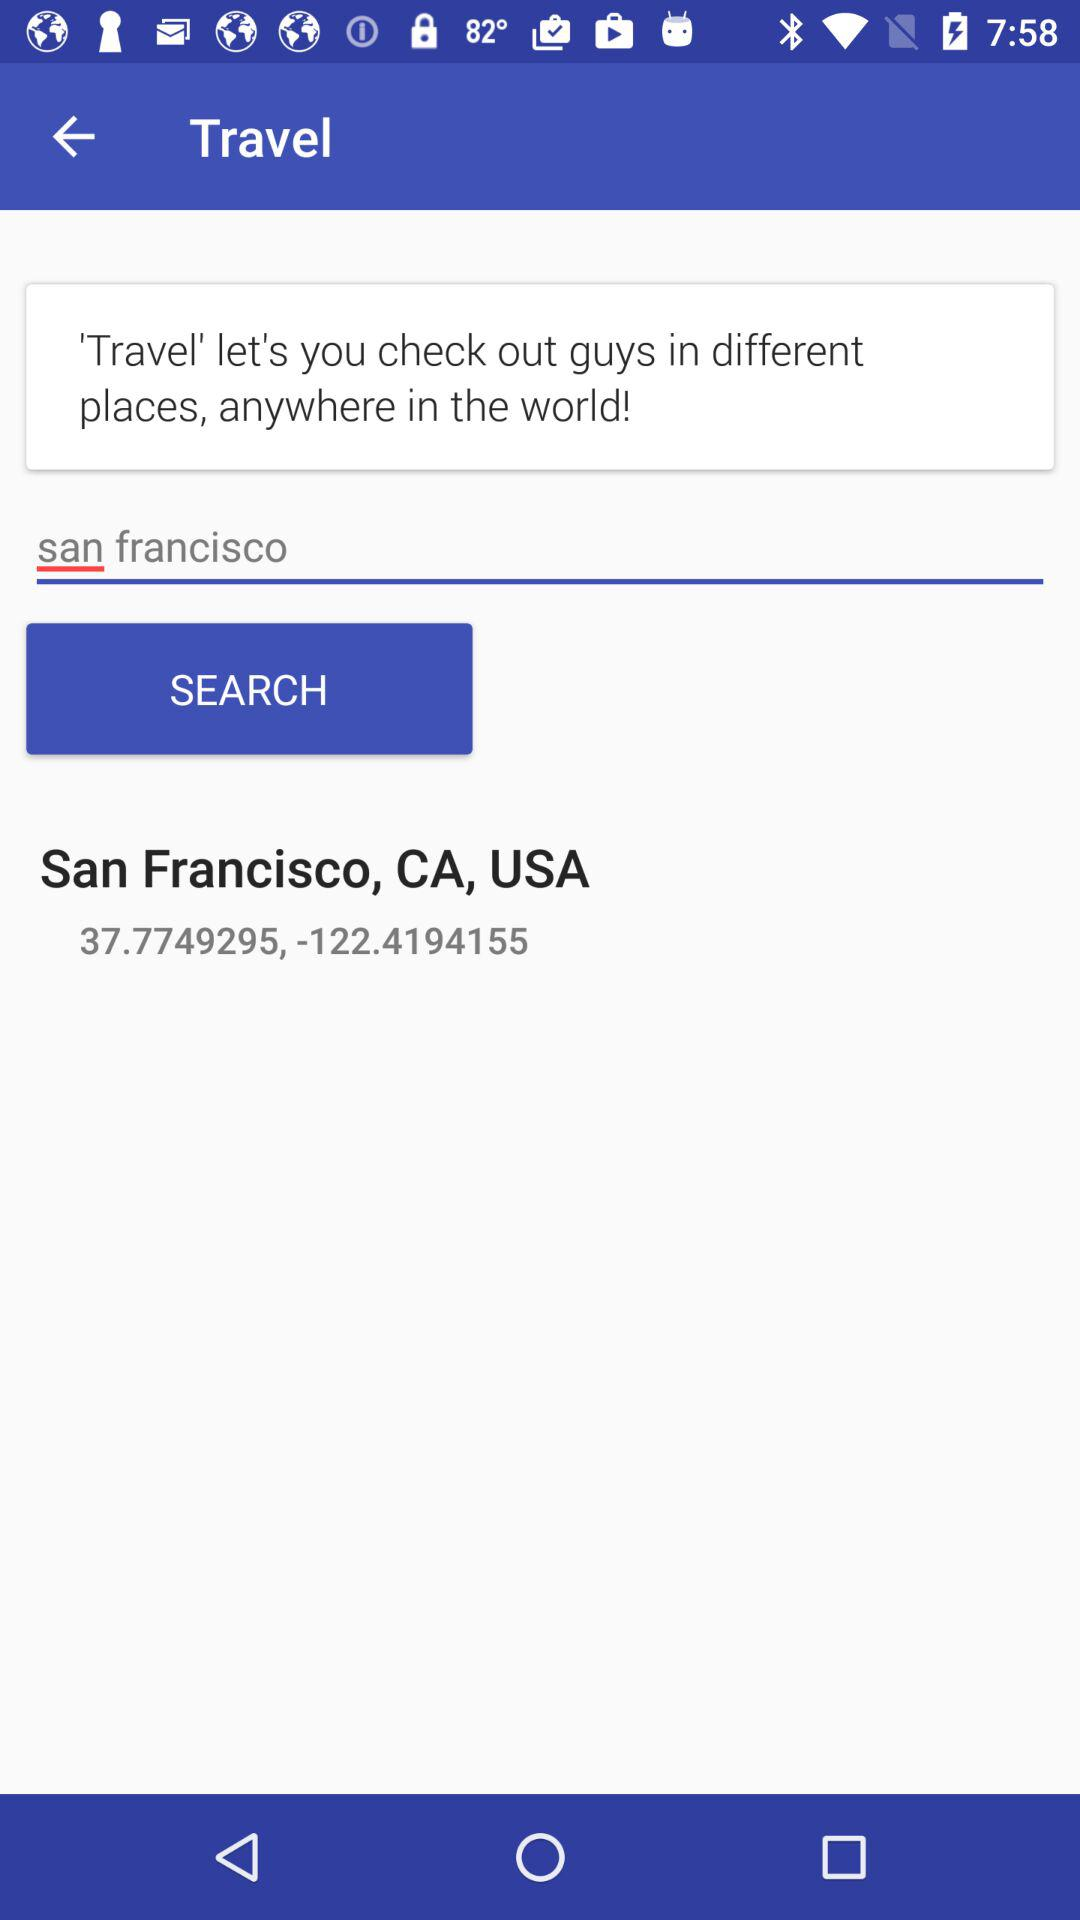What is the address?
When the provided information is insufficient, respond with <no answer>. <no answer> 